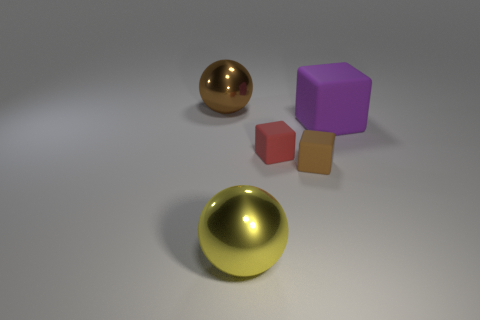Are there more yellow matte things than small red rubber blocks?
Your response must be concise. No. What number of big objects are both to the left of the purple rubber cube and to the right of the brown sphere?
Provide a succinct answer. 1. The large shiny object that is to the right of the metallic sphere that is left of the large sphere that is in front of the big purple matte object is what shape?
Your answer should be compact. Sphere. Is there any other thing that is the same shape as the large brown metal thing?
Provide a succinct answer. Yes. What number of spheres are large metal things or tiny green shiny objects?
Provide a short and direct response. 2. There is a small block that is in front of the red block; is its color the same as the big matte block?
Offer a terse response. No. The ball behind the large metallic sphere in front of the brown matte cube that is on the right side of the yellow sphere is made of what material?
Offer a very short reply. Metal. Do the red matte thing and the brown block have the same size?
Your answer should be compact. Yes. There is a brown object that is the same material as the purple cube; what is its shape?
Your response must be concise. Cube. Do the big metallic thing that is in front of the large matte block and the brown metal object have the same shape?
Offer a terse response. Yes. 